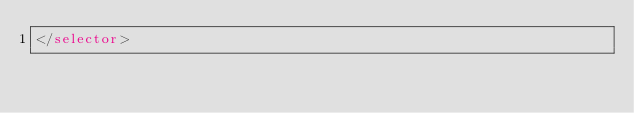<code> <loc_0><loc_0><loc_500><loc_500><_XML_></selector></code> 